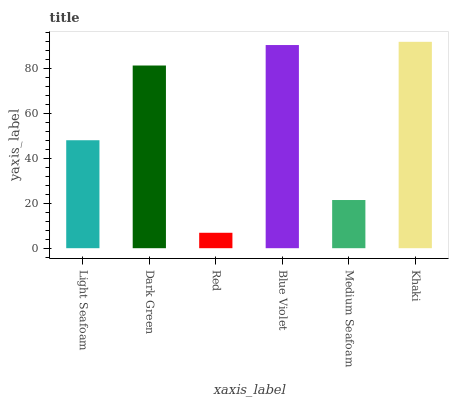Is Red the minimum?
Answer yes or no. Yes. Is Khaki the maximum?
Answer yes or no. Yes. Is Dark Green the minimum?
Answer yes or no. No. Is Dark Green the maximum?
Answer yes or no. No. Is Dark Green greater than Light Seafoam?
Answer yes or no. Yes. Is Light Seafoam less than Dark Green?
Answer yes or no. Yes. Is Light Seafoam greater than Dark Green?
Answer yes or no. No. Is Dark Green less than Light Seafoam?
Answer yes or no. No. Is Dark Green the high median?
Answer yes or no. Yes. Is Light Seafoam the low median?
Answer yes or no. Yes. Is Khaki the high median?
Answer yes or no. No. Is Khaki the low median?
Answer yes or no. No. 